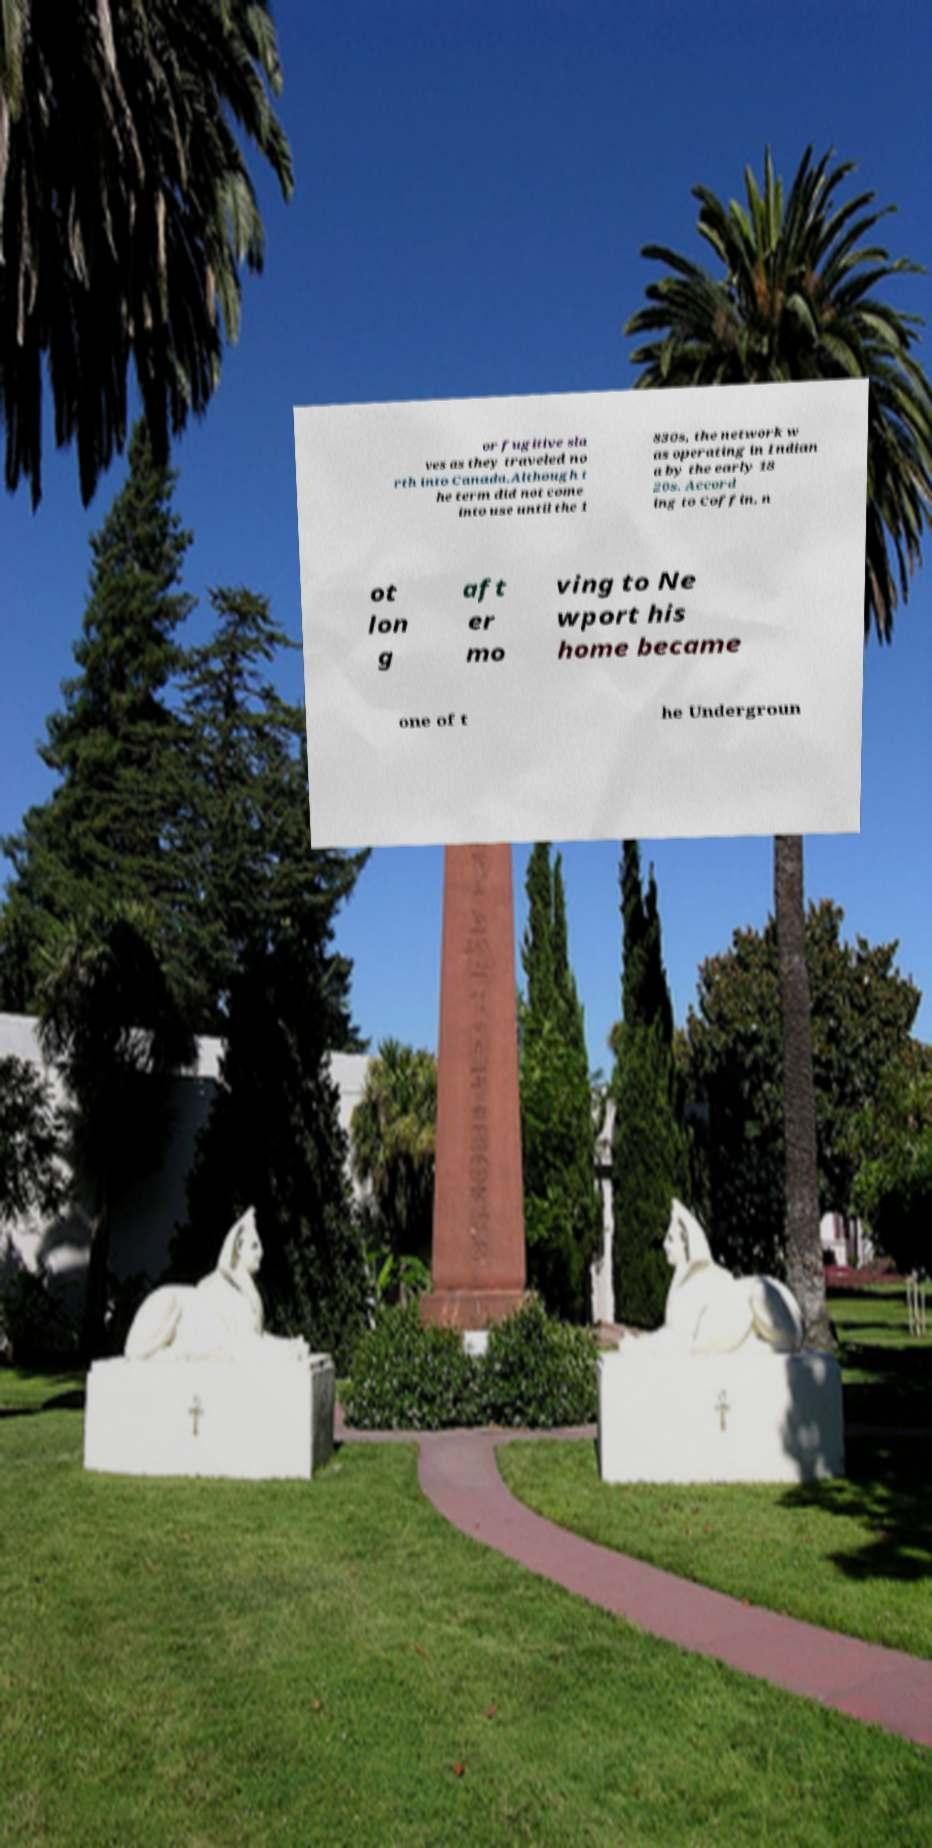Can you accurately transcribe the text from the provided image for me? or fugitive sla ves as they traveled no rth into Canada.Although t he term did not come into use until the 1 830s, the network w as operating in Indian a by the early 18 20s. Accord ing to Coffin, n ot lon g aft er mo ving to Ne wport his home became one of t he Undergroun 